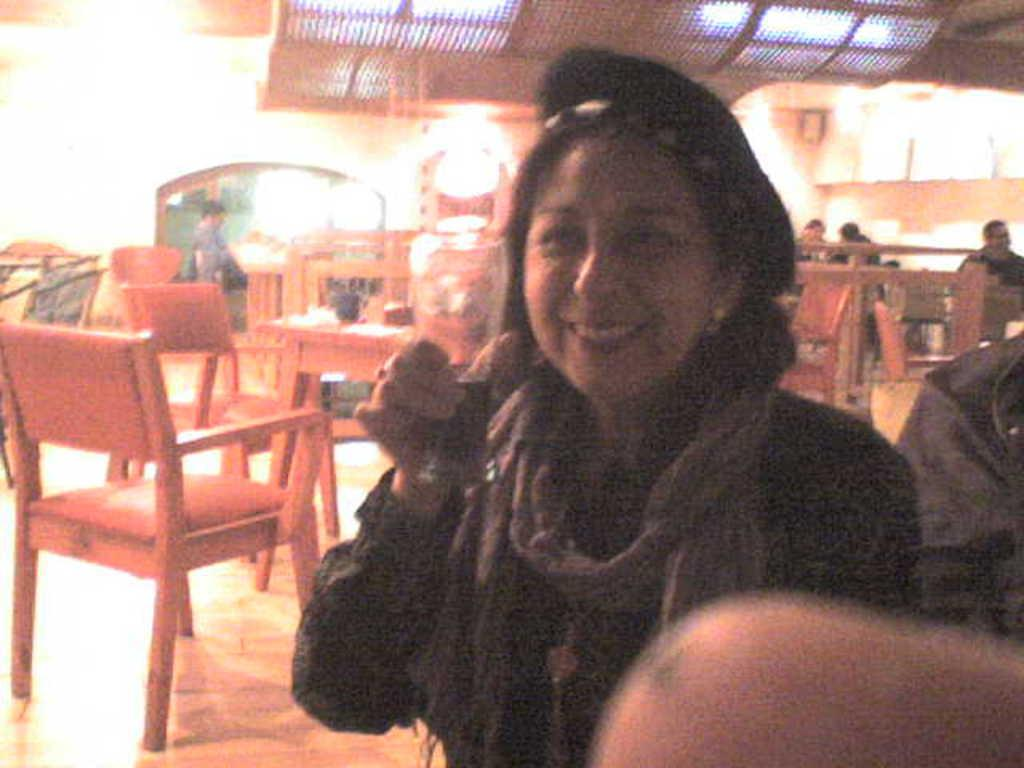Who is the main subject in the image? There is a woman in the image. What is the woman doing in the image? The woman is standing in the image. What object is the woman holding in her hand? The woman is holding a glass in her hand. What can be seen in the background of the image? There are people sitting in the background of the image. What type of stocking is the woman wearing in the image? There is no information about the woman's stockings in the image, so we cannot determine if she is wearing any or what type they might be. 